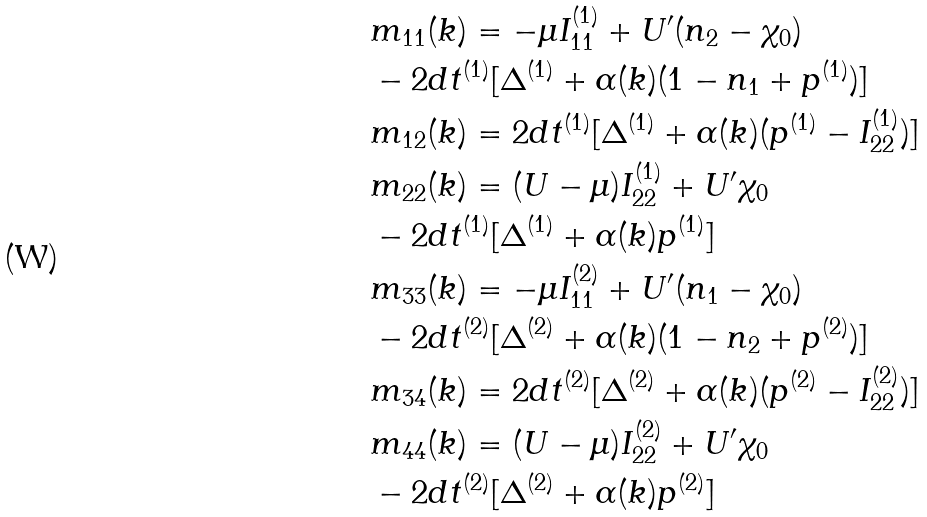<formula> <loc_0><loc_0><loc_500><loc_500>& m _ { 1 1 } ( k ) = - \mu I ^ { ( 1 ) } _ { 1 1 } + U ^ { \prime } ( n _ { 2 } - \chi _ { 0 } ) \\ & - 2 d t ^ { ( 1 ) } [ \Delta ^ { ( 1 ) } + \alpha ( k ) ( 1 - n _ { 1 } + p ^ { ( 1 ) } ) ] \\ & m _ { 1 2 } ( k ) = 2 d t ^ { ( 1 ) } [ \Delta ^ { ( 1 ) } + \alpha ( k ) ( p ^ { ( 1 ) } - I ^ { ( 1 ) } _ { 2 2 } ) ] \\ & m _ { 2 2 } ( k ) = ( U - \mu ) I ^ { ( 1 ) } _ { 2 2 } + U ^ { \prime } \chi _ { 0 } \\ & - 2 d t ^ { ( 1 ) } [ \Delta ^ { ( 1 ) } + \alpha ( k ) p ^ { ( 1 ) } ] \\ & m _ { 3 3 } ( k ) = - \mu I ^ { ( 2 ) } _ { 1 1 } + U ^ { \prime } ( n _ { 1 } - \chi _ { 0 } ) \\ & - 2 d t ^ { ( 2 ) } [ \Delta ^ { ( 2 ) } + \alpha ( k ) ( 1 - n _ { 2 } + p ^ { ( 2 ) } ) ] \\ & m _ { 3 4 } ( k ) = 2 d t ^ { ( 2 ) } [ \Delta ^ { ( 2 ) } + \alpha ( k ) ( p ^ { ( 2 ) } - I ^ { ( 2 ) } _ { 2 2 } ) ] \\ & m _ { 4 4 } ( k ) = ( U - \mu ) I ^ { ( 2 ) } _ { 2 2 } + U ^ { \prime } \chi _ { 0 } \\ & - 2 d t ^ { ( 2 ) } [ \Delta ^ { ( 2 ) } + \alpha ( k ) p ^ { ( 2 ) } ]</formula> 